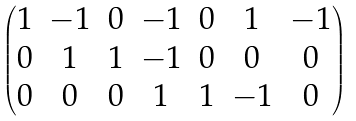Convert formula to latex. <formula><loc_0><loc_0><loc_500><loc_500>\begin{pmatrix} 1 & - 1 & 0 & - 1 & 0 & 1 & - 1 \\ 0 & 1 & 1 & - 1 & 0 & 0 & 0 \\ 0 & 0 & 0 & 1 & 1 & - 1 & 0 \end{pmatrix}</formula> 